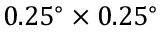<formula> <loc_0><loc_0><loc_500><loc_500>0 . 2 5 ^ { \circ } \times 0 . 2 5 ^ { \circ }</formula> 